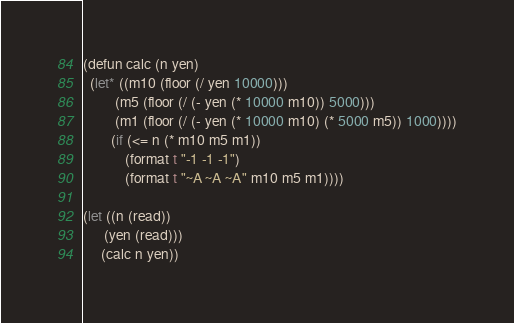<code> <loc_0><loc_0><loc_500><loc_500><_Lisp_>(defun calc (n yen)
  (let* ((m10 (floor (/ yen 10000)))
         (m5 (floor (/ (- yen (* 10000 m10)) 5000)))
         (m1 (floor (/ (- yen (* 10000 m10) (* 5000 m5)) 1000))))
        (if (<= n (* m10 m5 m1))
            (format t "-1 -1 -1")
            (format t "~A ~A ~A" m10 m5 m1))))

(let ((n (read))
      (yen (read)))
     (calc n yen))</code> 